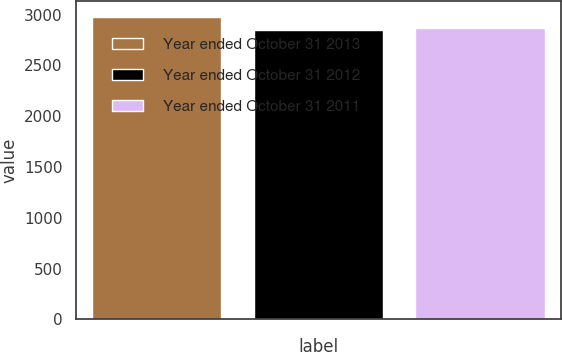<chart> <loc_0><loc_0><loc_500><loc_500><bar_chart><fcel>Year ended October 31 2013<fcel>Year ended October 31 2012<fcel>Year ended October 31 2011<nl><fcel>2980<fcel>2846<fcel>2864<nl></chart> 